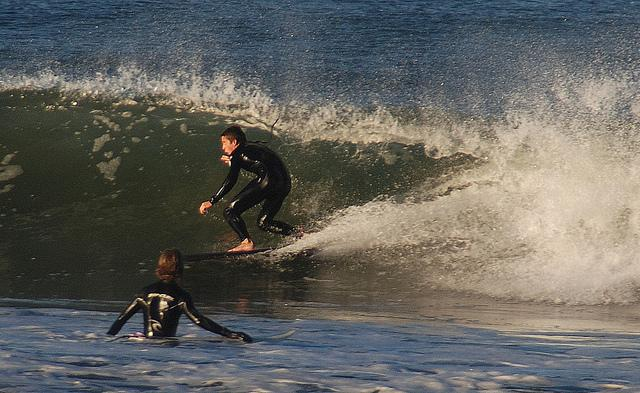Why is the man in black crouched? surfing 